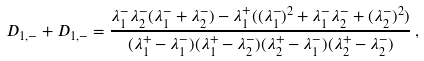<formula> <loc_0><loc_0><loc_500><loc_500>D _ { 1 , - } + D _ { 1 , - } = \frac { \lambda _ { 1 } ^ { - } \lambda _ { 2 } ^ { - } ( \lambda _ { 1 } ^ { - } + \lambda _ { 2 } ^ { - } ) - \lambda _ { 1 } ^ { + } ( ( \lambda _ { 1 } ^ { - } ) ^ { 2 } + \lambda _ { 1 } ^ { - } \lambda _ { 2 } ^ { - } + ( \lambda _ { 2 } ^ { - } ) ^ { 2 } ) } { ( \lambda _ { 1 } ^ { + } - \lambda _ { 1 } ^ { - } ) ( \lambda _ { 1 } ^ { + } - \lambda _ { 2 } ^ { - } ) ( \lambda _ { 2 } ^ { + } - \lambda _ { 1 } ^ { - } ) ( \lambda _ { 2 } ^ { + } - \lambda _ { 2 } ^ { - } ) } \, ,</formula> 